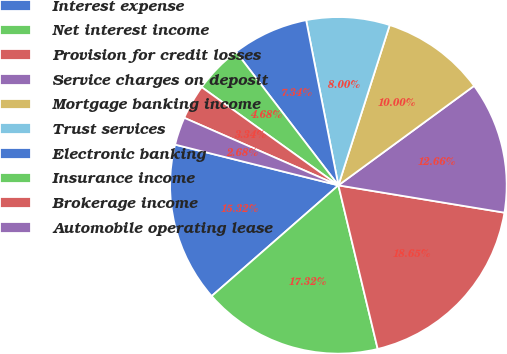Convert chart. <chart><loc_0><loc_0><loc_500><loc_500><pie_chart><fcel>Interest expense<fcel>Net interest income<fcel>Provision for credit losses<fcel>Service charges on deposit<fcel>Mortgage banking income<fcel>Trust services<fcel>Electronic banking<fcel>Insurance income<fcel>Brokerage income<fcel>Automobile operating lease<nl><fcel>15.32%<fcel>17.32%<fcel>18.65%<fcel>12.66%<fcel>10.0%<fcel>8.0%<fcel>7.34%<fcel>4.68%<fcel>3.34%<fcel>2.68%<nl></chart> 